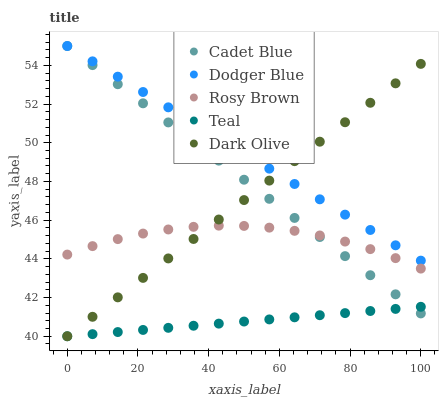Does Teal have the minimum area under the curve?
Answer yes or no. Yes. Does Dodger Blue have the maximum area under the curve?
Answer yes or no. Yes. Does Rosy Brown have the minimum area under the curve?
Answer yes or no. No. Does Rosy Brown have the maximum area under the curve?
Answer yes or no. No. Is Teal the smoothest?
Answer yes or no. Yes. Is Rosy Brown the roughest?
Answer yes or no. Yes. Is Cadet Blue the smoothest?
Answer yes or no. No. Is Cadet Blue the roughest?
Answer yes or no. No. Does Dark Olive have the lowest value?
Answer yes or no. Yes. Does Rosy Brown have the lowest value?
Answer yes or no. No. Does Dodger Blue have the highest value?
Answer yes or no. Yes. Does Rosy Brown have the highest value?
Answer yes or no. No. Is Rosy Brown less than Dodger Blue?
Answer yes or no. Yes. Is Dodger Blue greater than Teal?
Answer yes or no. Yes. Does Rosy Brown intersect Cadet Blue?
Answer yes or no. Yes. Is Rosy Brown less than Cadet Blue?
Answer yes or no. No. Is Rosy Brown greater than Cadet Blue?
Answer yes or no. No. Does Rosy Brown intersect Dodger Blue?
Answer yes or no. No. 